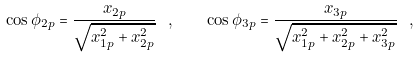Convert formula to latex. <formula><loc_0><loc_0><loc_500><loc_500>\cos \phi _ { 2 p } = \frac { x _ { 2 p } } { \sqrt { x _ { 1 p } ^ { 2 } + x _ { 2 p } ^ { 2 } } } \ , \quad \cos \phi _ { 3 p } = \frac { x _ { 3 p } } { \sqrt { x _ { 1 p } ^ { 2 } + x _ { 2 p } ^ { 2 } + x _ { 3 p } ^ { 2 } } } \ ,</formula> 